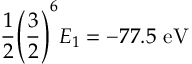<formula> <loc_0><loc_0><loc_500><loc_500>{ \frac { 1 } { 2 } } { \left ( } { \frac { 3 } { 2 } } { \right ) } ^ { 6 } E _ { 1 } = - 7 7 . 5 { e V }</formula> 